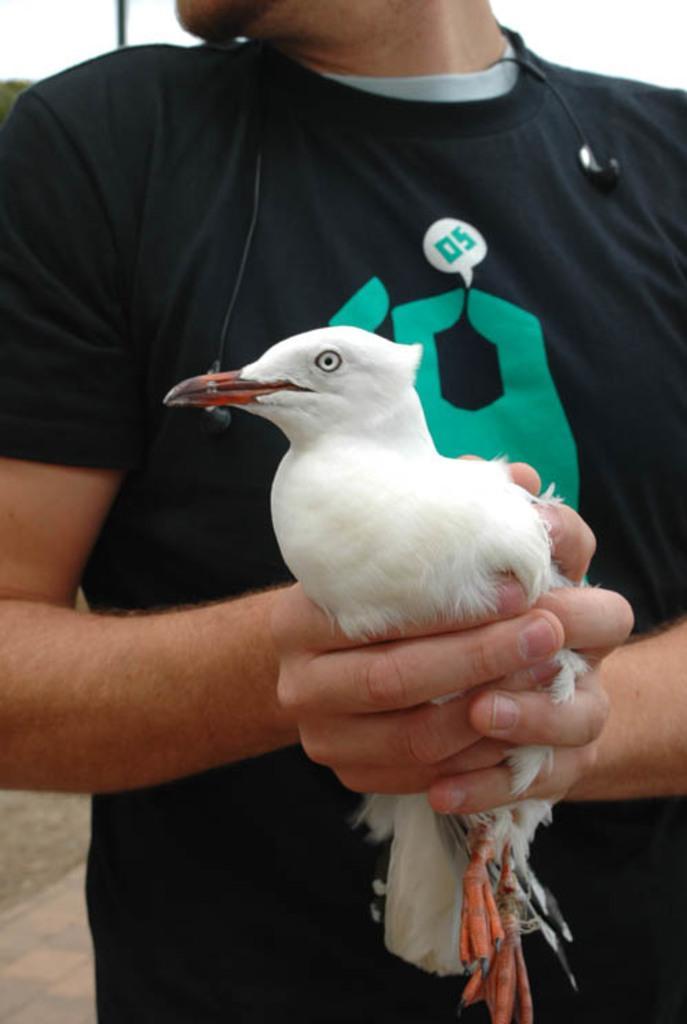How would you summarize this image in a sentence or two? In this picture we can see a man holding a bird with his hands and in the background we can see the ground and the sky. 